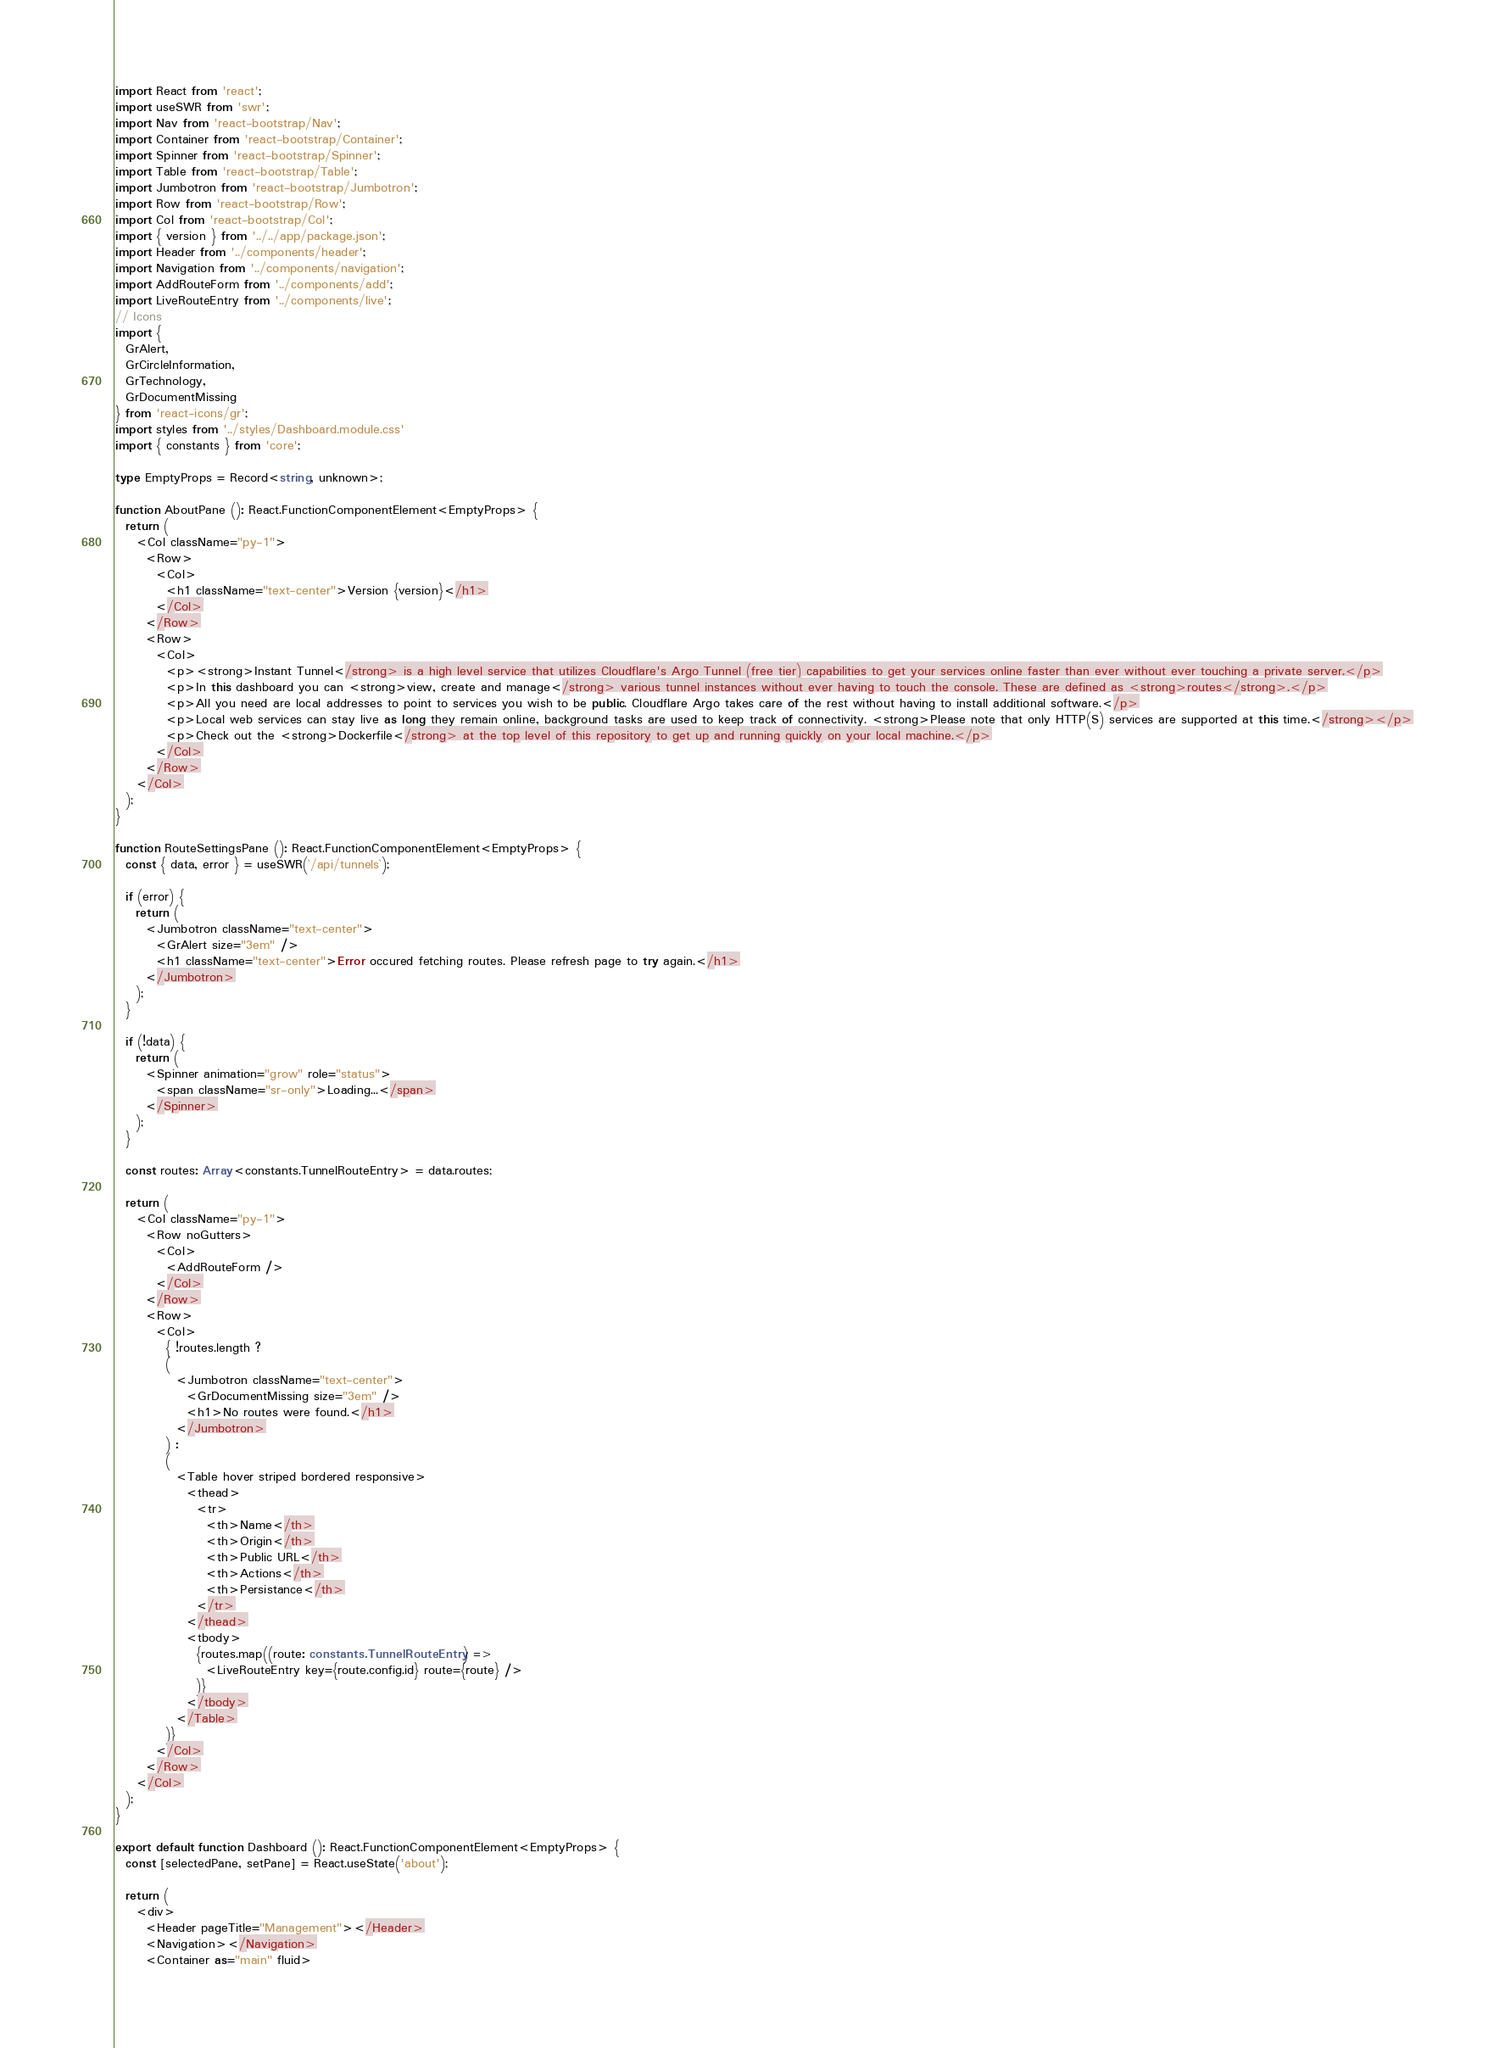Convert code to text. <code><loc_0><loc_0><loc_500><loc_500><_TypeScript_>import React from 'react';
import useSWR from 'swr';
import Nav from 'react-bootstrap/Nav';
import Container from 'react-bootstrap/Container';
import Spinner from 'react-bootstrap/Spinner';
import Table from 'react-bootstrap/Table';
import Jumbotron from 'react-bootstrap/Jumbotron';
import Row from 'react-bootstrap/Row';
import Col from 'react-bootstrap/Col';
import { version } from '../../app/package.json';
import Header from '../components/header';
import Navigation from '../components/navigation';
import AddRouteForm from '../components/add';
import LiveRouteEntry from '../components/live';
// Icons
import {
  GrAlert,
  GrCircleInformation,
  GrTechnology,
  GrDocumentMissing
} from 'react-icons/gr'; 
import styles from '../styles/Dashboard.module.css'
import { constants } from 'core';

type EmptyProps = Record<string, unknown>;

function AboutPane (): React.FunctionComponentElement<EmptyProps> {
  return (
    <Col className="py-1">
      <Row>
        <Col>
          <h1 className="text-center">Version {version}</h1>
        </Col>
      </Row>
      <Row>
        <Col>
          <p><strong>Instant Tunnel</strong> is a high level service that utilizes Cloudflare's Argo Tunnel (free tier) capabilities to get your services online faster than ever without ever touching a private server.</p>
          <p>In this dashboard you can <strong>view, create and manage</strong> various tunnel instances without ever having to touch the console. These are defined as <strong>routes</strong>.</p>
          <p>All you need are local addresses to point to services you wish to be public. Cloudflare Argo takes care of the rest without having to install additional software.</p>
          <p>Local web services can stay live as long they remain online, background tasks are used to keep track of connectivity. <strong>Please note that only HTTP(S) services are supported at this time.</strong></p>
          <p>Check out the <strong>Dockerfile</strong> at the top level of this repository to get up and running quickly on your local machine.</p>
        </Col>
      </Row>
    </Col>
  );
}

function RouteSettingsPane (): React.FunctionComponentElement<EmptyProps> {
  const { data, error } = useSWR(`/api/tunnels`);

  if (error) {
    return (
      <Jumbotron className="text-center">
        <GrAlert size="3em" />
        <h1 className="text-center">Error occured fetching routes. Please refresh page to try again.</h1>
      </Jumbotron>
    );
  }

  if (!data) {
    return (
      <Spinner animation="grow" role="status">
        <span className="sr-only">Loading...</span>
      </Spinner>
    );
  }

  const routes: Array<constants.TunnelRouteEntry> = data.routes;
  
  return (
    <Col className="py-1">
      <Row noGutters>
        <Col>
          <AddRouteForm />
        </Col>
      </Row>
      <Row>
        <Col>
          { !routes.length ? 
          (
            <Jumbotron className="text-center">
              <GrDocumentMissing size="3em" />
              <h1>No routes were found.</h1>
            </Jumbotron>
          ) : 
          (
            <Table hover striped bordered responsive>
              <thead>
                <tr>
                  <th>Name</th>
                  <th>Origin</th>
                  <th>Public URL</th>
                  <th>Actions</th>
                  <th>Persistance</th>
                </tr>
              </thead>
              <tbody>
                {routes.map((route: constants.TunnelRouteEntry) => 
                  <LiveRouteEntry key={route.config.id} route={route} />
                )}
              </tbody>
            </Table>
          )}
        </Col>
      </Row>
    </Col>
  );
}

export default function Dashboard (): React.FunctionComponentElement<EmptyProps> {
  const [selectedPane, setPane] = React.useState('about');

  return (
    <div>
      <Header pageTitle="Management"></Header>
      <Navigation></Navigation>
      <Container as="main" fluid></code> 